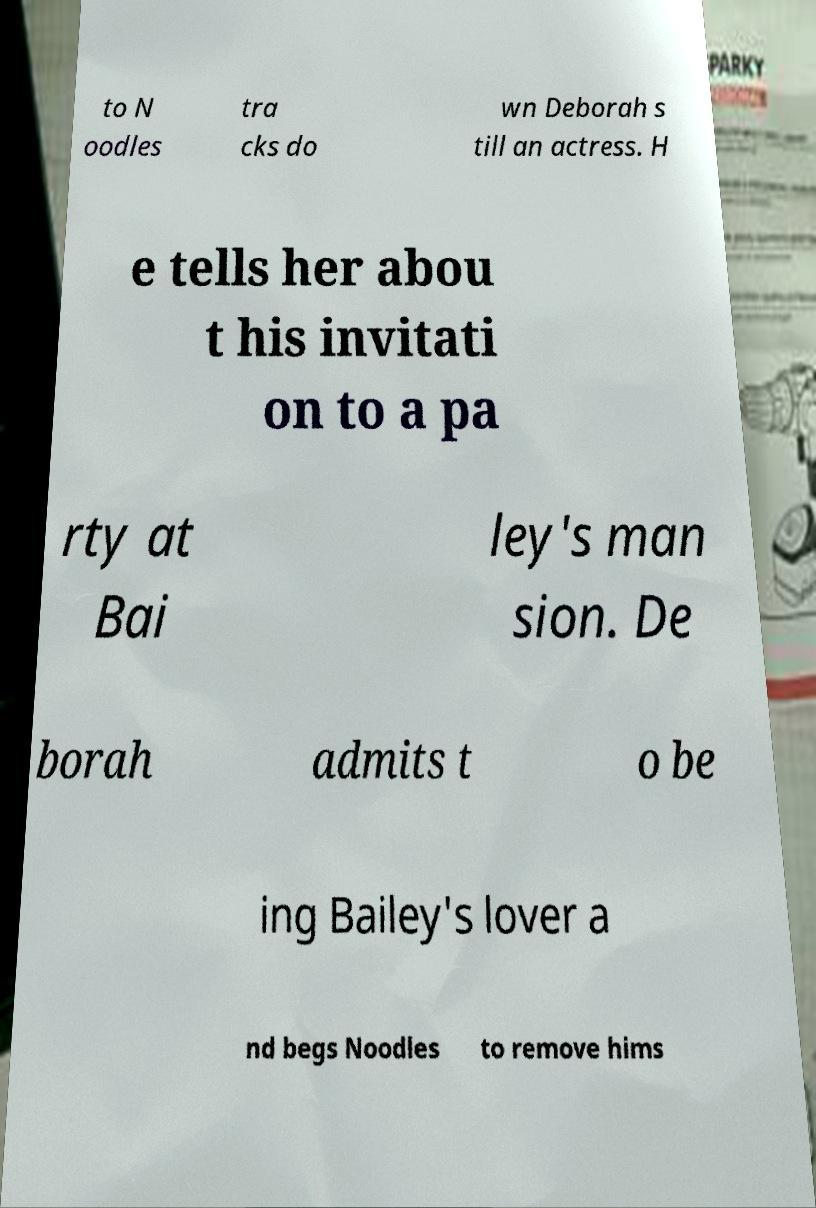Can you read and provide the text displayed in the image?This photo seems to have some interesting text. Can you extract and type it out for me? to N oodles tra cks do wn Deborah s till an actress. H e tells her abou t his invitati on to a pa rty at Bai ley's man sion. De borah admits t o be ing Bailey's lover a nd begs Noodles to remove hims 